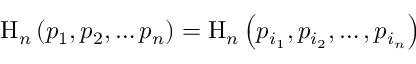Convert formula to latex. <formula><loc_0><loc_0><loc_500><loc_500>H _ { n } \left ( p _ { 1 } , p _ { 2 } , \dots p _ { n } \right ) = H _ { n } \left ( p _ { i _ { 1 } } , p _ { i _ { 2 } } , \dots , p _ { i _ { n } } \right )</formula> 